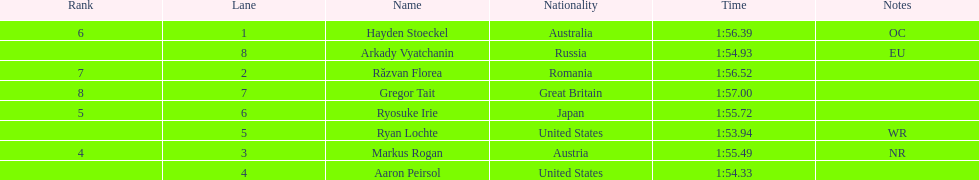How long did it take ryosuke irie to finish? 1:55.72. 